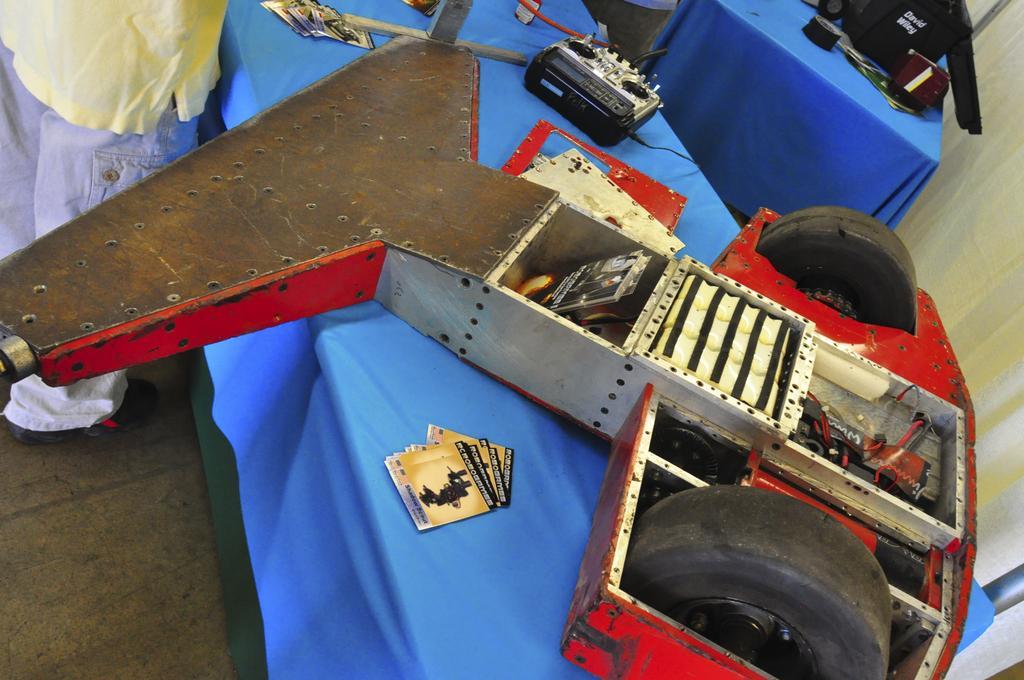How would you summarize this image in a sentence or two? In the foreground of this picture, there is a sports car part on a blue table and there is a person standing on the top left corner. In the background, there are tables and on one table there is a pole and electronic equipment. On an another table there are few objects on it. 